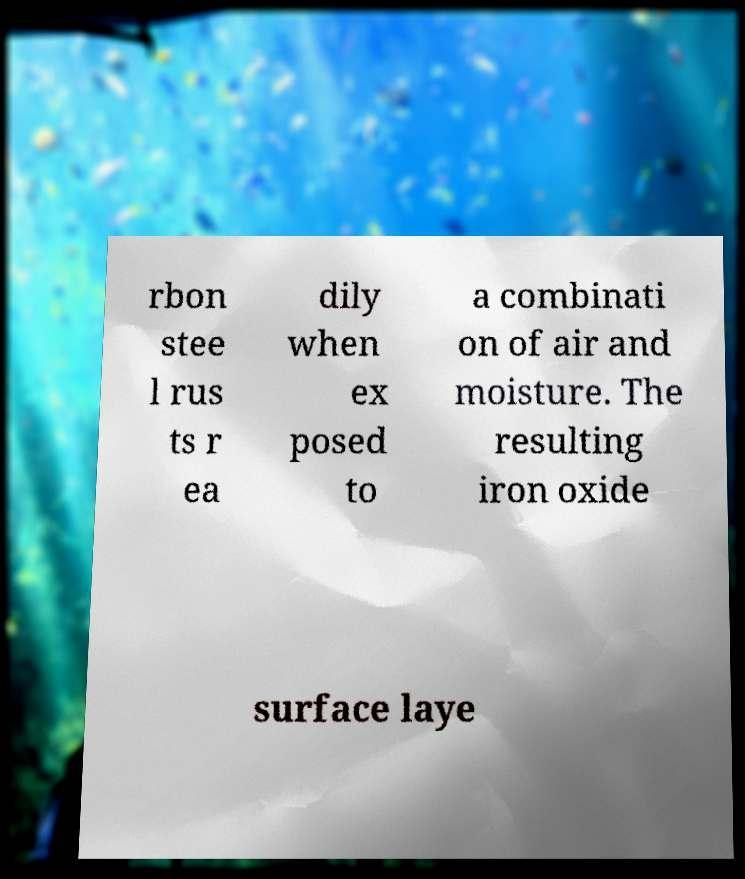Can you read and provide the text displayed in the image?This photo seems to have some interesting text. Can you extract and type it out for me? rbon stee l rus ts r ea dily when ex posed to a combinati on of air and moisture. The resulting iron oxide surface laye 